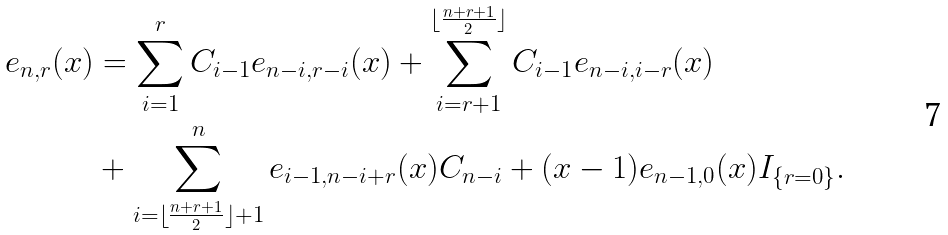Convert formula to latex. <formula><loc_0><loc_0><loc_500><loc_500>e _ { n , r } ( x ) & = \sum _ { i = 1 } ^ { r } C _ { i - 1 } e _ { n - i , r - i } ( x ) + \sum _ { i = r + 1 } ^ { \lfloor \frac { n + r + 1 } { 2 } \rfloor } C _ { i - 1 } e _ { n - i , i - r } ( x ) \\ & + \sum _ { i = \lfloor \frac { n + r + 1 } { 2 } \rfloor + 1 } ^ { n } e _ { i - 1 , n - i + r } ( x ) C _ { n - i } + ( x - 1 ) e _ { n - 1 , 0 } ( x ) I _ { \{ r = 0 \} } .</formula> 